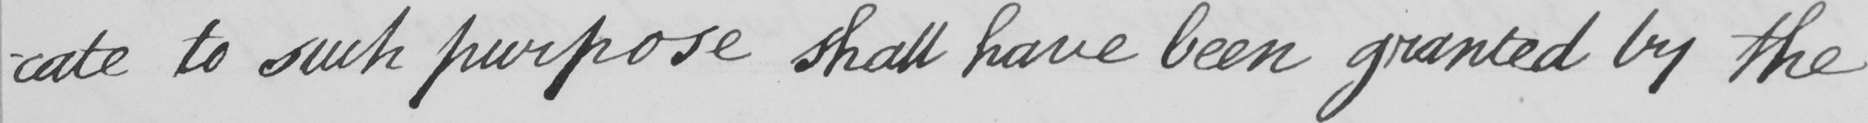Can you tell me what this handwritten text says? -cate to such purpose shall have been granted by the 